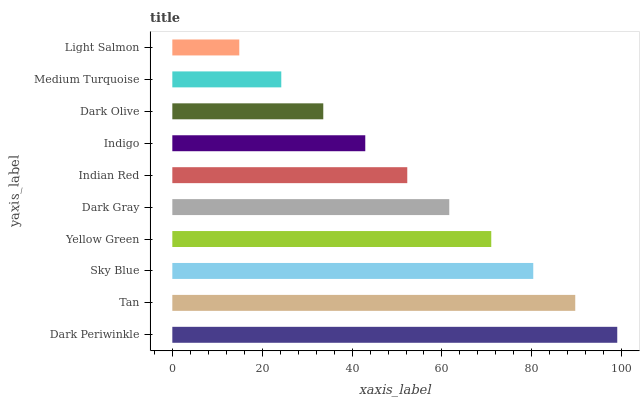Is Light Salmon the minimum?
Answer yes or no. Yes. Is Dark Periwinkle the maximum?
Answer yes or no. Yes. Is Tan the minimum?
Answer yes or no. No. Is Tan the maximum?
Answer yes or no. No. Is Dark Periwinkle greater than Tan?
Answer yes or no. Yes. Is Tan less than Dark Periwinkle?
Answer yes or no. Yes. Is Tan greater than Dark Periwinkle?
Answer yes or no. No. Is Dark Periwinkle less than Tan?
Answer yes or no. No. Is Dark Gray the high median?
Answer yes or no. Yes. Is Indian Red the low median?
Answer yes or no. Yes. Is Dark Periwinkle the high median?
Answer yes or no. No. Is Light Salmon the low median?
Answer yes or no. No. 